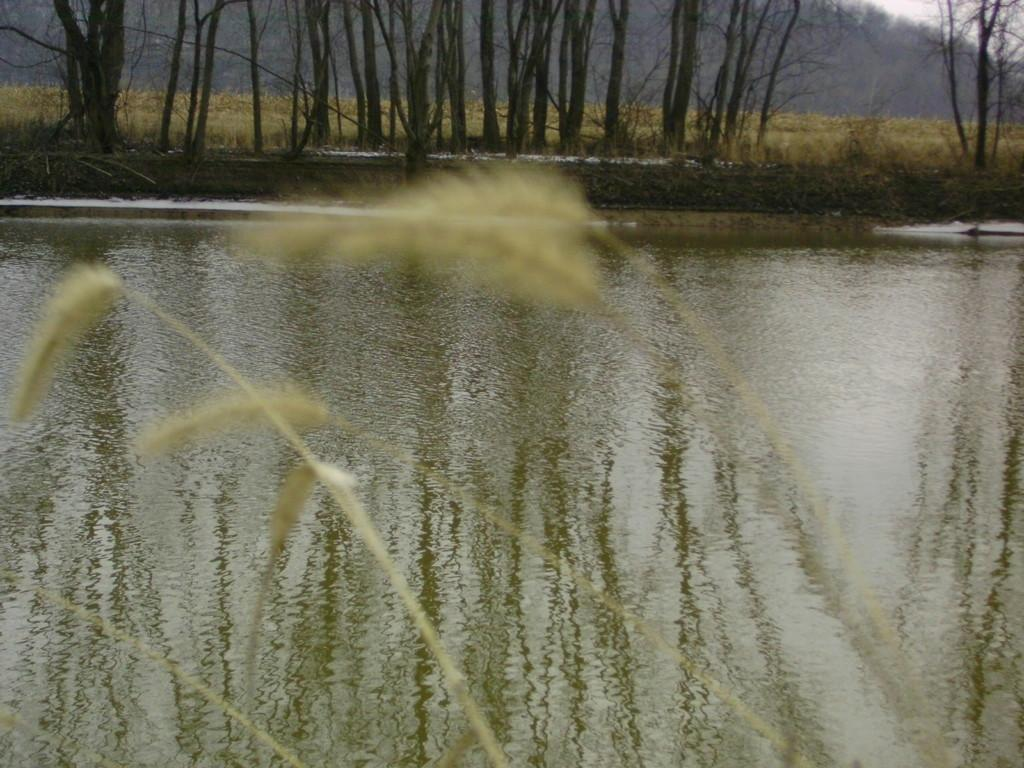What type of vegetation is in the foreground of the image? There are plants in the foreground of the image. What body of water is visible at the bottom of the image? There is a river at the bottom of the image. What type of vegetation and natural elements can be seen in the background of the image? There are trees, grass, and plants in the background of the image. Can you see any mice running around the plants in the image? There are no mice visible in the image; it only features plants, a river, trees, grass, and plants in the background. Is there a flame burning in the river at the bottom of the image? There is no flame present in the image; it only features plants, a river, trees, grass, and plants in the background. 